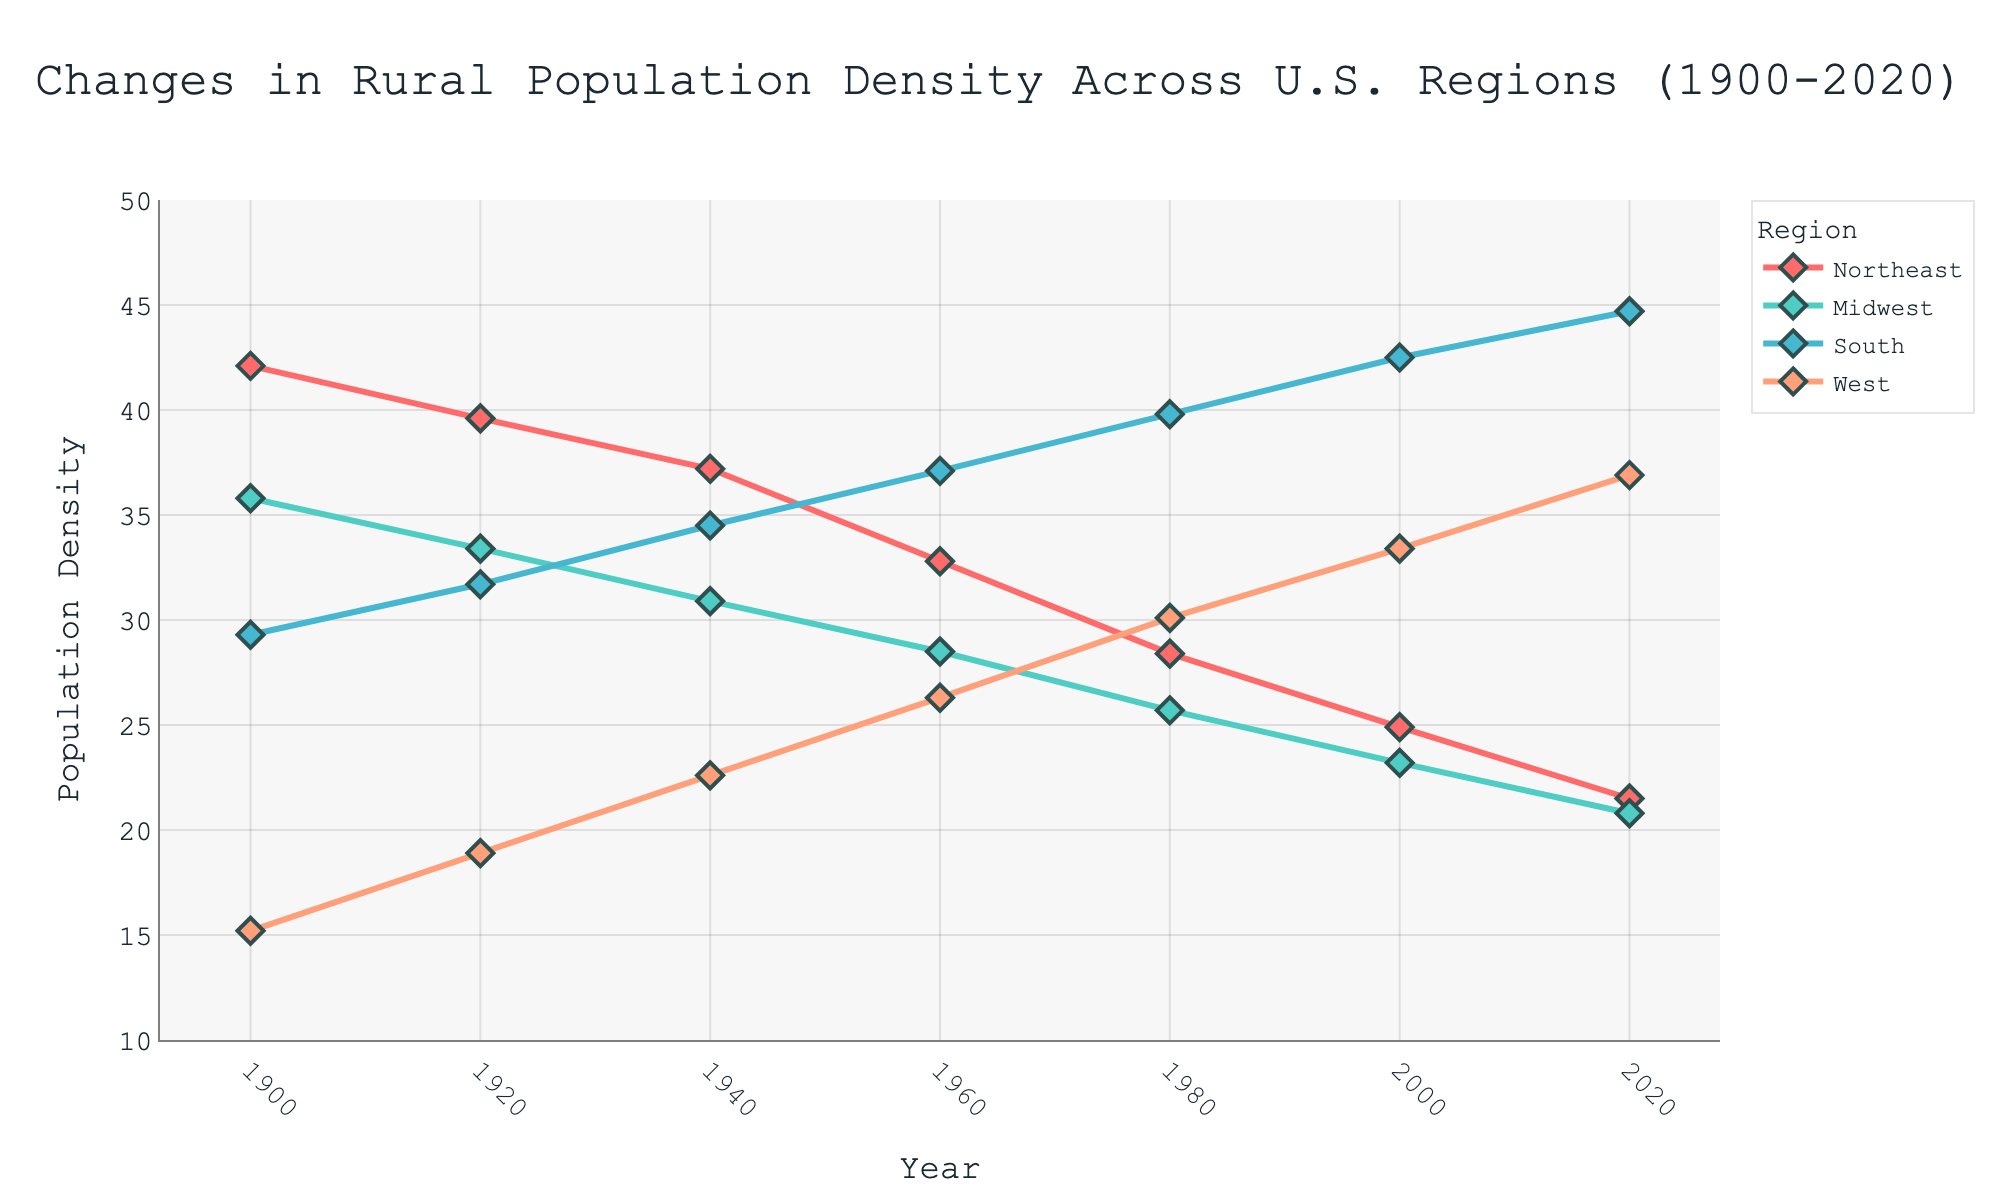What's the trend in rural population density for the Northeast region from 1900 to 2020? By observing the red line representing the Northeast region over the years, we see a consistent decline from 42.1 in 1900 to 21.5 in 2020.
Answer: Decreasing Which region experienced the highest rural population density increase from 1900 to 2020? Calculate the difference between 2020 and 1900 for all regions: Northeast (21.5 - 42.1 = -20.6), Midwest (20.8 - 35.8 = -15), South (44.7 - 29.3 = 15.4), West (36.9 - 15.2 = 21.7). The West had the highest increase.
Answer: West What was the rural population density for the South region in 1940, and is it greater than that of the Northeast in the same year? The South region's density in 1940 is 34.5, and the Northeast's density in the same year is 37.2. 34.5 is less than 37.2.
Answer: No Which region had the lowest rural population density in 1900, and what was it? The values for 1900 are: Northeast (42.1), Midwest (35.8), South (29.3), and West (15.2). The West had the lowest density at 15.2.
Answer: West, 15.2 What is the average rural population density for the Midwest from 1900 to 2020? The values for the Midwest are: 35.8 (1900), 33.4 (1920), 30.9 (1940), 28.5 (1960), 25.7 (1980), 23.2 (2000), and 20.8 (2020). Summing these values: 35.8 + 33.4 + 30.9 + 28.5 + 25.7 + 23.2 + 20.8 = 198.3. Dividing by 7 gives an average of approximately 28.33.
Answer: 28.33 Which two regions had the closest rural population densities in 2020, and what were their densities? The values for 2020 are: Northeast (21.5), Midwest (20.8), South (44.7), West (36.9). The closest values are for Northeast and Midwest, with densities of 21.5 and 20.8 respectively.
Answer: Northeast (21.5), Midwest (20.8) How much did the rural population density change for the South region from 1960 to 1980? The values for the South are: 37.1 in 1960 and 39.8 in 1980. The change is 39.8 - 37.1 = 2.7.
Answer: 2.7 Did any region have a consistently increasing trend from 1900 to 2020? The South and West regions show an increasing trend. By examining their lines, they both rise from 1900 to 2020 without any dips below their previous values for consecutive years.
Answer: Yes, South and West 